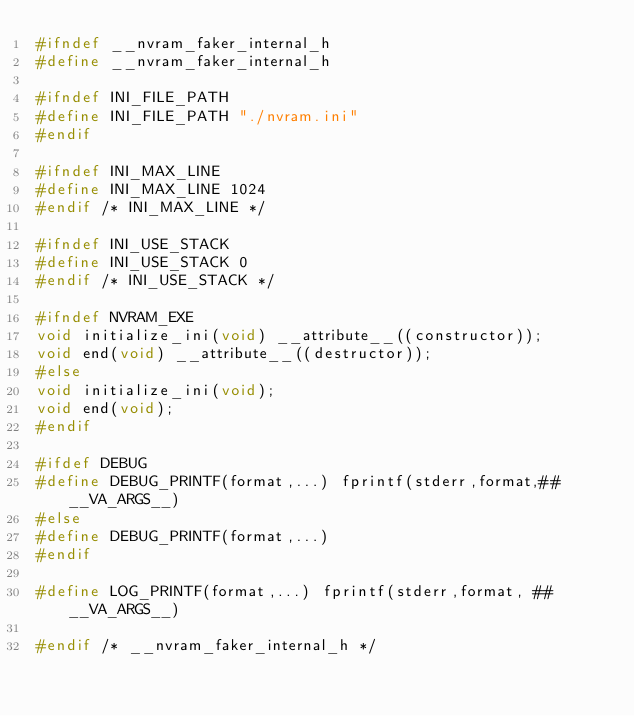Convert code to text. <code><loc_0><loc_0><loc_500><loc_500><_C_>#ifndef __nvram_faker_internal_h
#define __nvram_faker_internal_h

#ifndef INI_FILE_PATH
#define INI_FILE_PATH "./nvram.ini"
#endif

#ifndef INI_MAX_LINE
#define INI_MAX_LINE 1024
#endif /* INI_MAX_LINE */

#ifndef INI_USE_STACK
#define INI_USE_STACK 0
#endif /* INI_USE_STACK */

#ifndef NVRAM_EXE
void initialize_ini(void) __attribute__((constructor));
void end(void) __attribute__((destructor));
#else
void initialize_ini(void);
void end(void);
#endif

#ifdef DEBUG
#define DEBUG_PRINTF(format,...) fprintf(stderr,format,## __VA_ARGS__)
#else
#define DEBUG_PRINTF(format,...)
#endif

#define LOG_PRINTF(format,...) fprintf(stderr,format, ## __VA_ARGS__)

#endif /* __nvram_faker_internal_h */</code> 